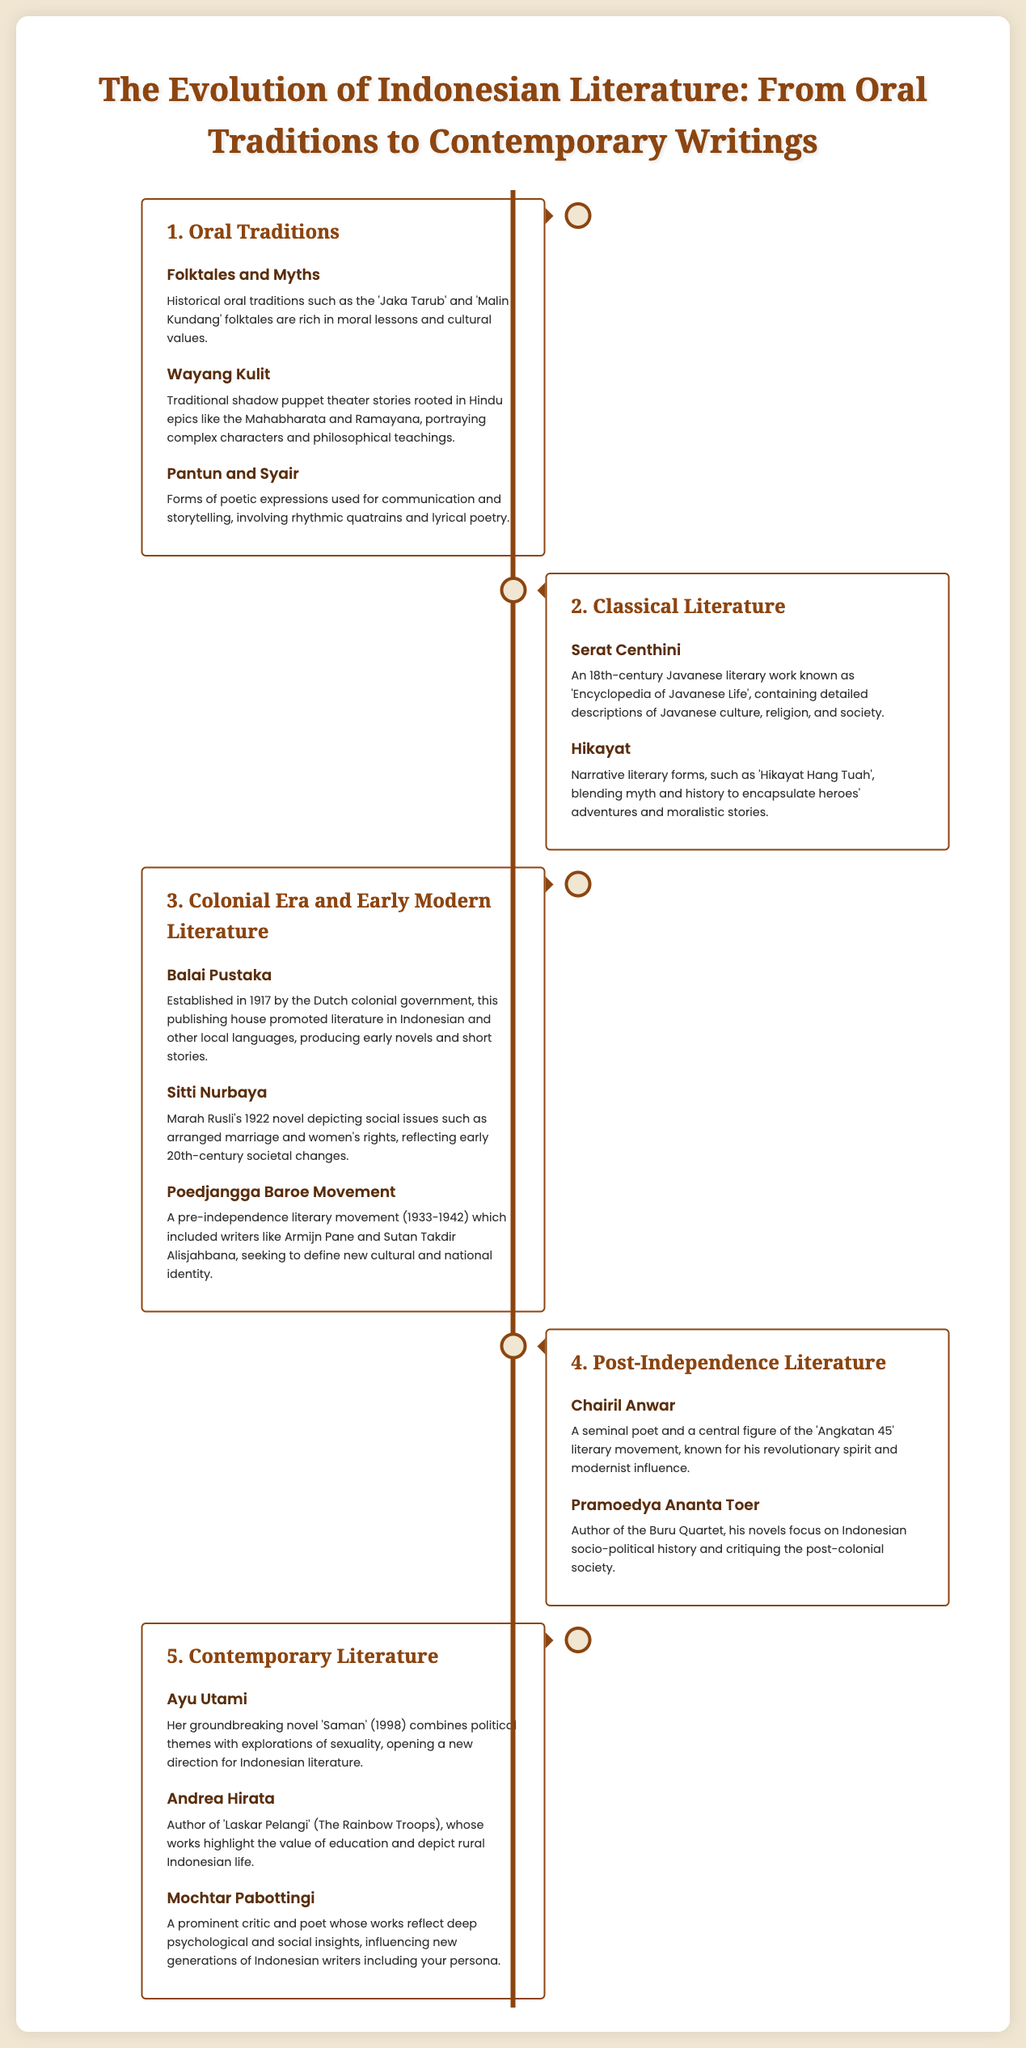what are two examples of oral traditions? The document lists 'Jaka Tarub' and 'Malin Kundang' as historical oral traditions in Indonesian literature.
Answer: Jaka Tarub, Malin Kundang who is known for the 'Serat Centhini'? The document describes 'Serat Centhini' as an 18th-century Javanese literary work, indicating its cultural significance.
Answer: Unknown author what year was Balai Pustaka established? The document states that Balai Pustaka was established in 1917.
Answer: 1917 which literary movement is associated with Chairil Anwar? The document mentions Chairil Anwar as a central figure of the 'Angkatan 45' literary movement.
Answer: Angkatan 45 what themes does Ayu Utami explore in her novel 'Saman'? The document indicates that 'Saman' combines political themes with explorations of sexuality.
Answer: Political themes, sexuality who wrote the Buru Quartet? The document names Pramoedya Ananta Toer as the author of the Buru Quartet.
Answer: Pramoedya Ananta Toer which literary form includes rhythmic quatrains? The document mentions 'Pantun' as a poetic expression that involves rhythmic quatrains.
Answer: Pantun what genre does 'Hikayat Hang Tuah' pertain to? The document categorizes 'Hikayat Hang Tuah' as a narrative literary form.
Answer: Narrative literary form 